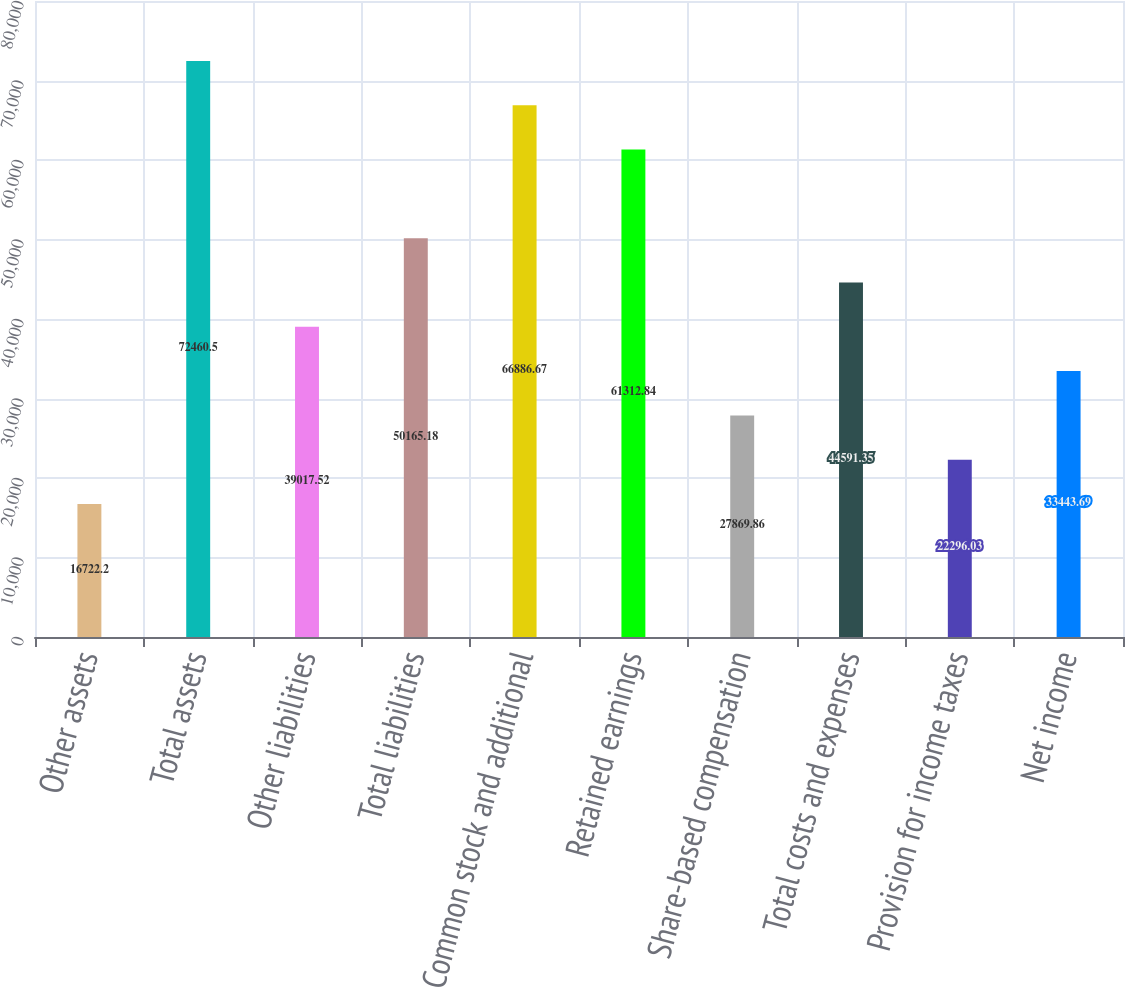Convert chart. <chart><loc_0><loc_0><loc_500><loc_500><bar_chart><fcel>Other assets<fcel>Total assets<fcel>Other liabilities<fcel>Total liabilities<fcel>Common stock and additional<fcel>Retained earnings<fcel>Share-based compensation<fcel>Total costs and expenses<fcel>Provision for income taxes<fcel>Net income<nl><fcel>16722.2<fcel>72460.5<fcel>39017.5<fcel>50165.2<fcel>66886.7<fcel>61312.8<fcel>27869.9<fcel>44591.3<fcel>22296<fcel>33443.7<nl></chart> 